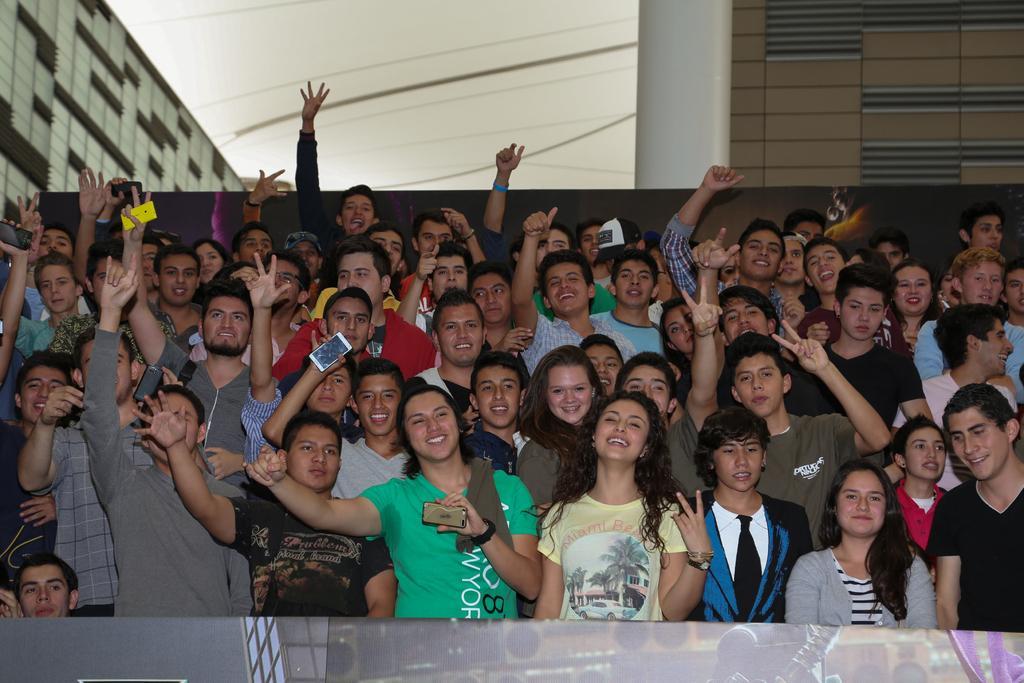Could you give a brief overview of what you see in this image? In this image I can see group of people standing and smiling and holding some objects and in the background i can see two buildings, the sky and the wires. And at the bottom of the image i can see an object 